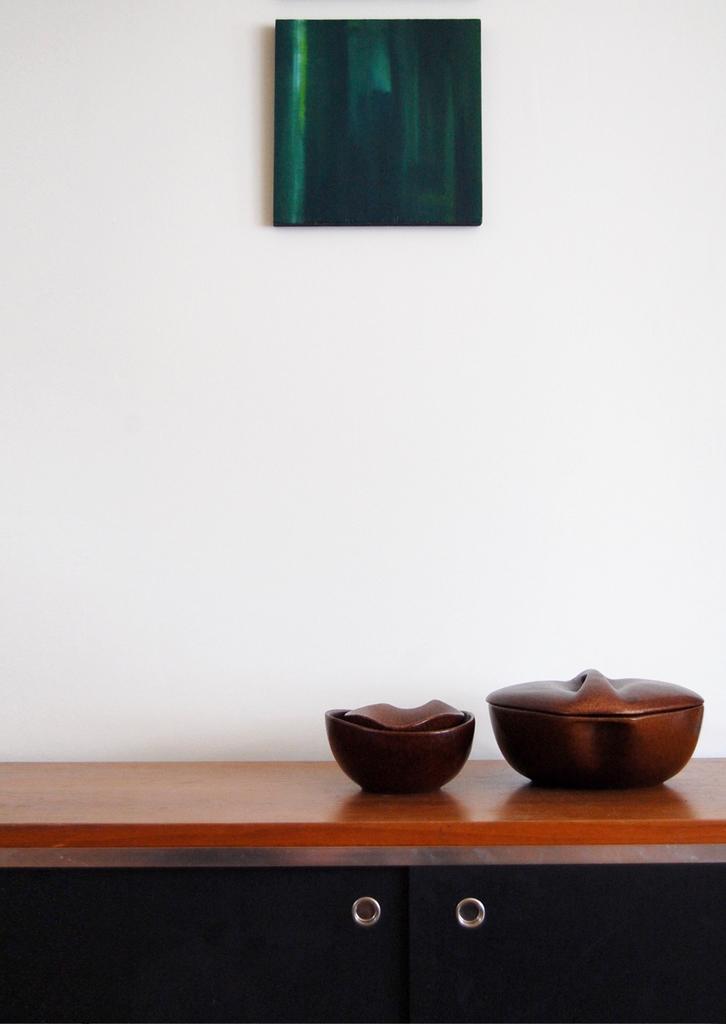Could you give a brief overview of what you see in this image? In this image I can see two bowls. They are on the brown color table. I can see a green color frame attached to the wall. The wall is in white color. 